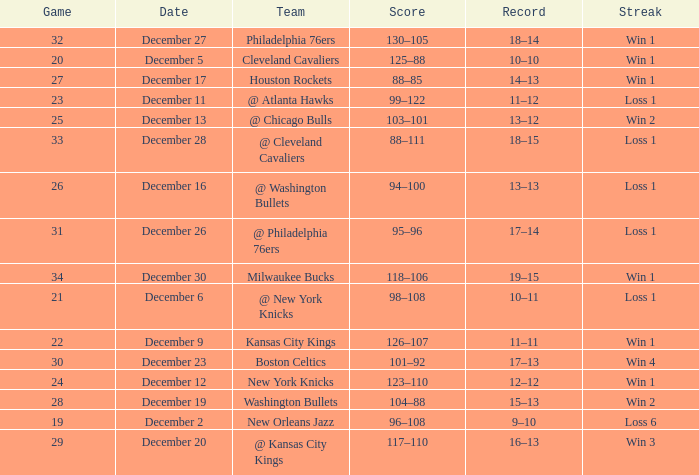What Game had a Score of 101–92? 30.0. 